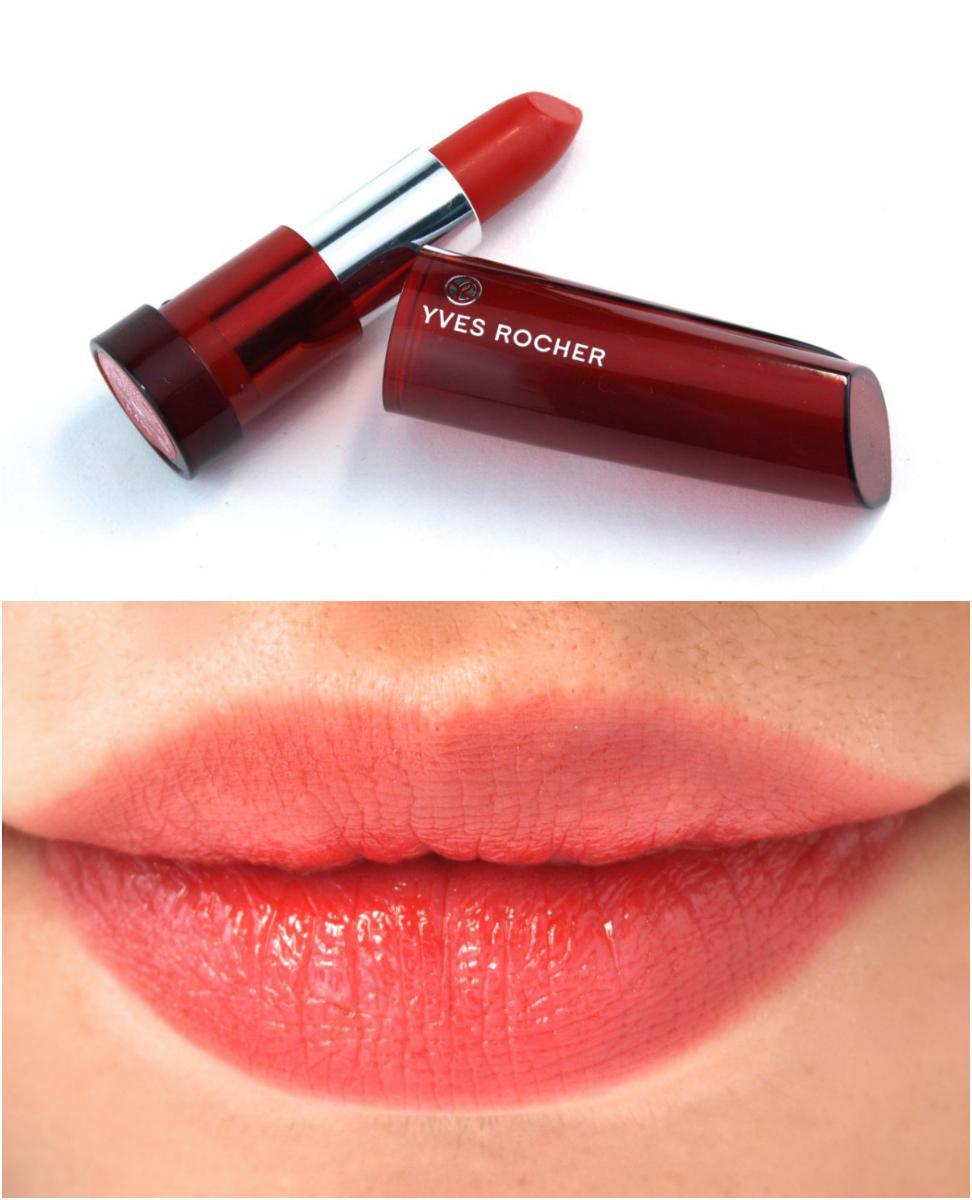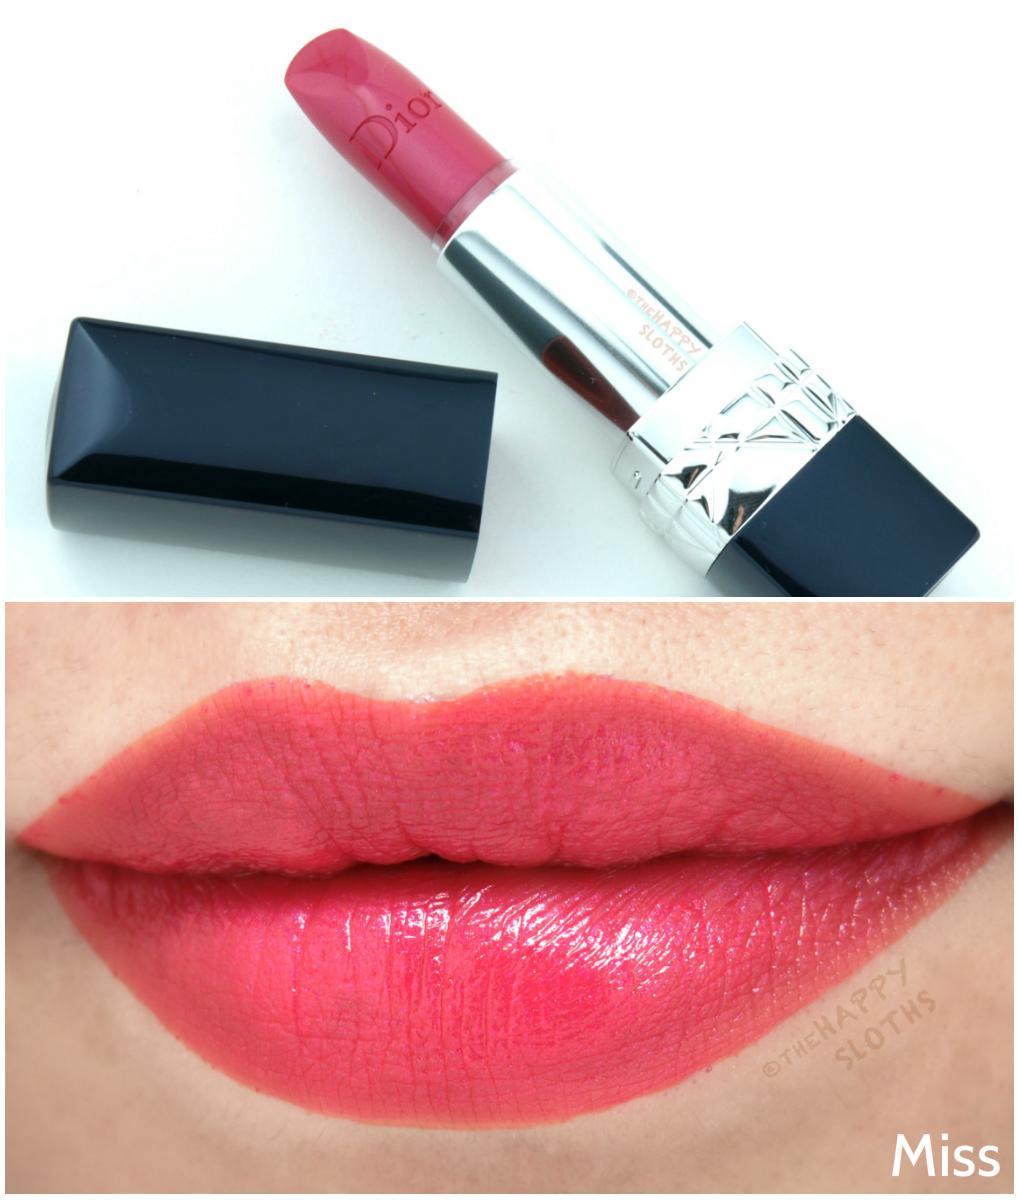The first image is the image on the left, the second image is the image on the right. Considering the images on both sides, is "The lipstick on the left comes in a red case." valid? Answer yes or no. Yes. 